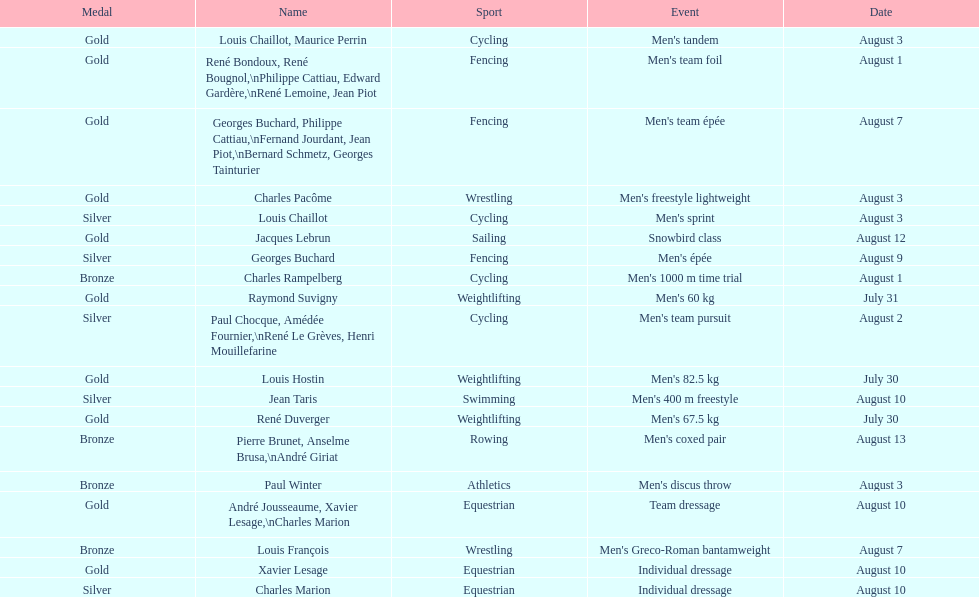Which occasion garnered the highest number of medals? Cycling. 